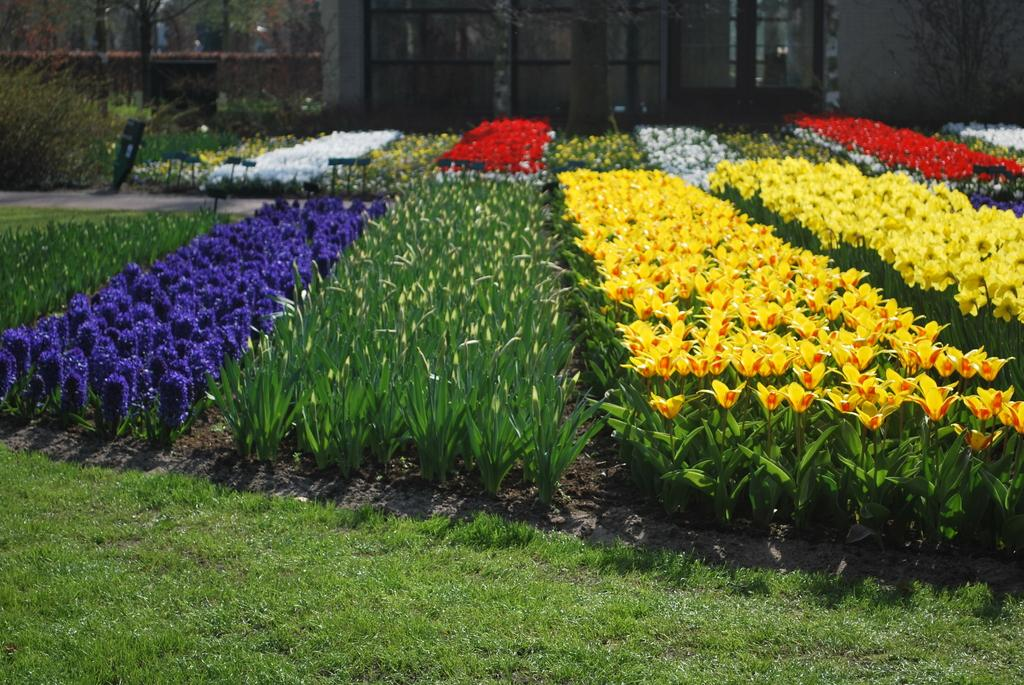What type of vegetation can be seen in the image? There are plants, flowers, and trees in the image. What type of structure is visible in the image? There is a wall in the image. What architectural features can be seen in the image? There are glass windows and a door in the image. What type of ground surface is visible in the image? There is grass visible in the image. What else can be seen in the image besides the vegetation and structure? There are objects in the image. What type of club can be seen in the image? There is no club present in the image. What type of party is taking place in the image? There is no party present in the image. 